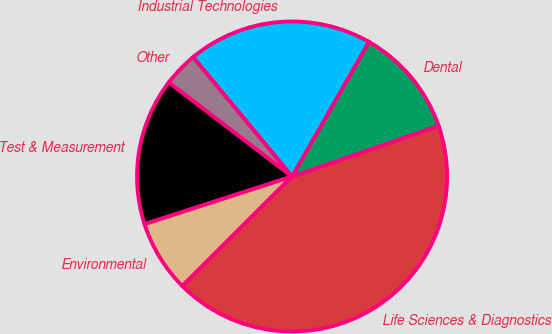Convert chart to OTSL. <chart><loc_0><loc_0><loc_500><loc_500><pie_chart><fcel>Test & Measurement<fcel>Environmental<fcel>Life Sciences & Diagnostics<fcel>Dental<fcel>Industrial Technologies<fcel>Other<nl><fcel>15.36%<fcel>7.51%<fcel>42.82%<fcel>11.44%<fcel>19.28%<fcel>3.59%<nl></chart> 